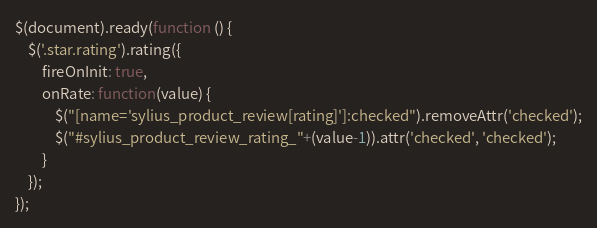Convert code to text. <code><loc_0><loc_0><loc_500><loc_500><_JavaScript_>$(document).ready(function () {
    $('.star.rating').rating({
        fireOnInit: true,
        onRate: function(value) {
            $("[name='sylius_product_review[rating]']:checked").removeAttr('checked');
            $("#sylius_product_review_rating_"+(value-1)).attr('checked', 'checked');
        }
    });
});
</code> 